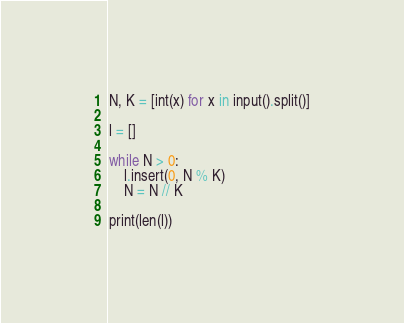<code> <loc_0><loc_0><loc_500><loc_500><_Python_>N, K = [int(x) for x in input().split()]

l = []

while N > 0:
    l.insert(0, N % K)
    N = N // K

print(len(l))
</code> 